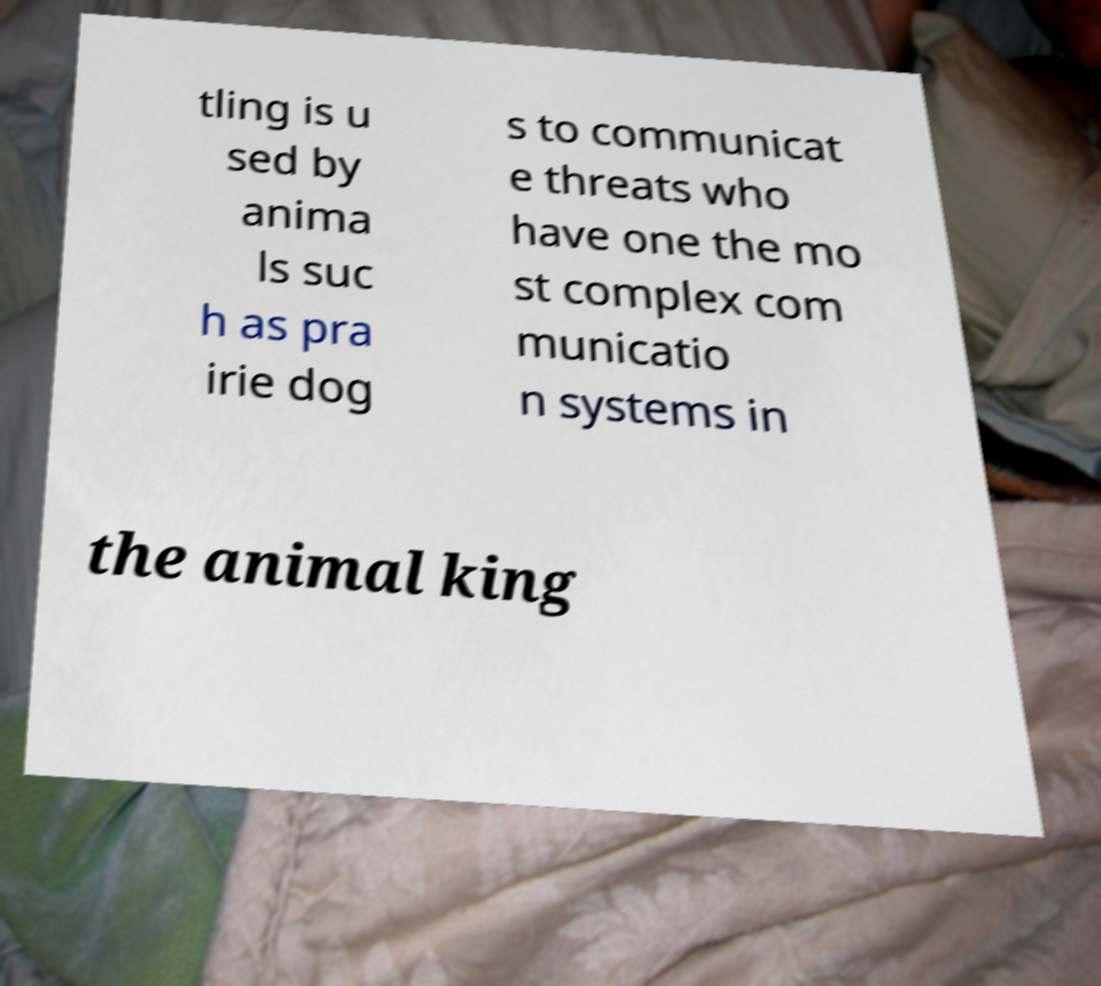Could you assist in decoding the text presented in this image and type it out clearly? tling is u sed by anima ls suc h as pra irie dog s to communicat e threats who have one the mo st complex com municatio n systems in the animal king 